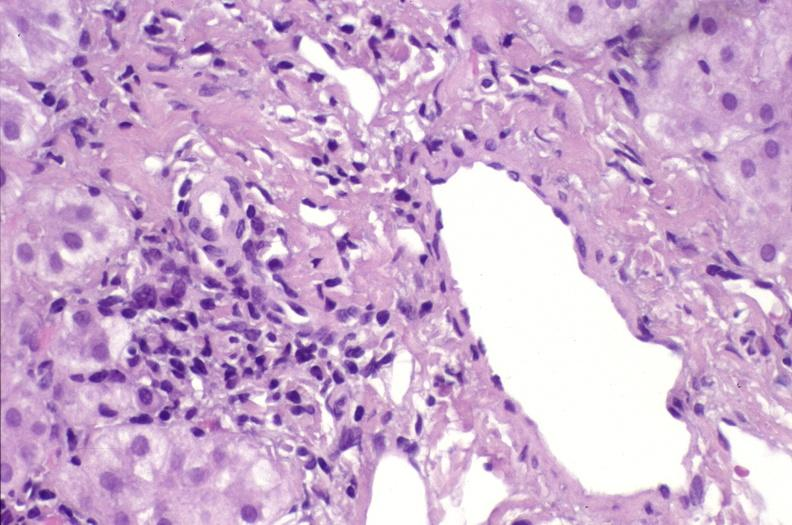what is present?
Answer the question using a single word or phrase. Hepatobiliary 